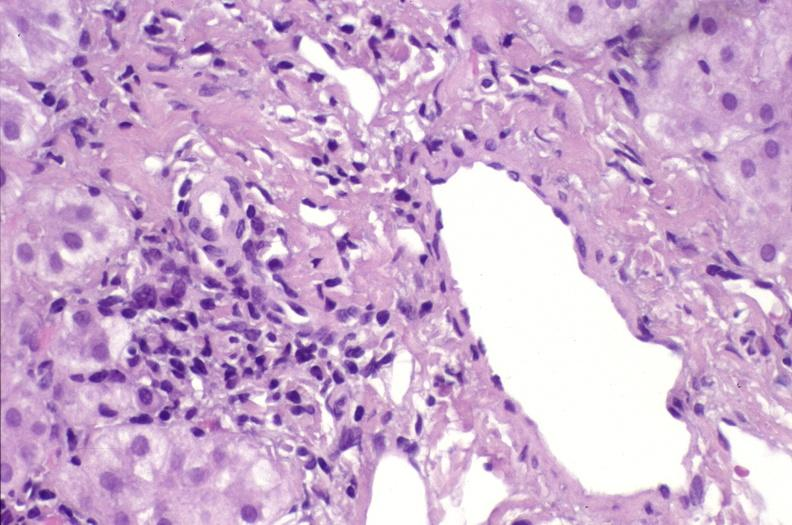what is present?
Answer the question using a single word or phrase. Hepatobiliary 